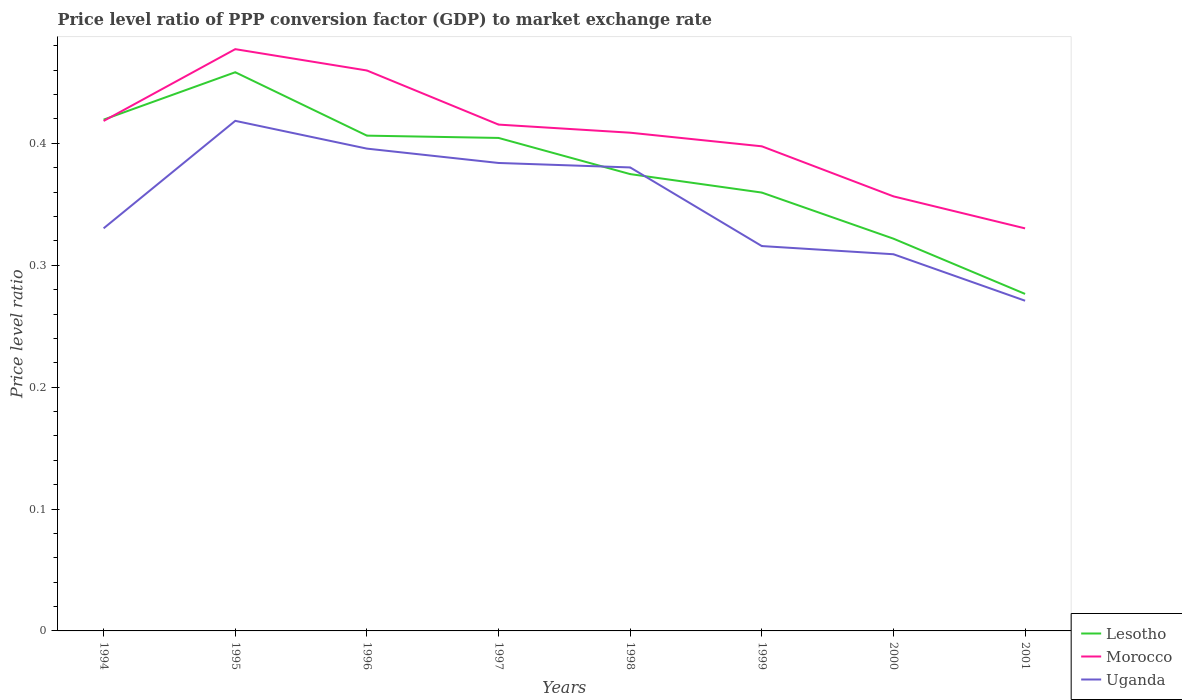How many different coloured lines are there?
Provide a short and direct response. 3. Is the number of lines equal to the number of legend labels?
Provide a succinct answer. Yes. Across all years, what is the maximum price level ratio in Lesotho?
Keep it short and to the point. 0.28. In which year was the price level ratio in Lesotho maximum?
Offer a very short reply. 2001. What is the total price level ratio in Lesotho in the graph?
Keep it short and to the point. 0.14. What is the difference between the highest and the second highest price level ratio in Uganda?
Offer a very short reply. 0.15. Is the price level ratio in Uganda strictly greater than the price level ratio in Morocco over the years?
Your response must be concise. Yes. How many years are there in the graph?
Keep it short and to the point. 8. Does the graph contain any zero values?
Make the answer very short. No. Where does the legend appear in the graph?
Make the answer very short. Bottom right. How are the legend labels stacked?
Offer a very short reply. Vertical. What is the title of the graph?
Give a very brief answer. Price level ratio of PPP conversion factor (GDP) to market exchange rate. Does "Europe(developing only)" appear as one of the legend labels in the graph?
Keep it short and to the point. No. What is the label or title of the Y-axis?
Make the answer very short. Price level ratio. What is the Price level ratio of Lesotho in 1994?
Keep it short and to the point. 0.42. What is the Price level ratio in Morocco in 1994?
Offer a very short reply. 0.42. What is the Price level ratio of Uganda in 1994?
Ensure brevity in your answer.  0.33. What is the Price level ratio of Lesotho in 1995?
Offer a very short reply. 0.46. What is the Price level ratio of Morocco in 1995?
Keep it short and to the point. 0.48. What is the Price level ratio of Uganda in 1995?
Keep it short and to the point. 0.42. What is the Price level ratio of Lesotho in 1996?
Ensure brevity in your answer.  0.41. What is the Price level ratio in Morocco in 1996?
Your response must be concise. 0.46. What is the Price level ratio in Uganda in 1996?
Ensure brevity in your answer.  0.4. What is the Price level ratio in Lesotho in 1997?
Your response must be concise. 0.4. What is the Price level ratio of Morocco in 1997?
Your answer should be very brief. 0.42. What is the Price level ratio of Uganda in 1997?
Offer a terse response. 0.38. What is the Price level ratio of Lesotho in 1998?
Provide a short and direct response. 0.37. What is the Price level ratio of Morocco in 1998?
Make the answer very short. 0.41. What is the Price level ratio of Uganda in 1998?
Your response must be concise. 0.38. What is the Price level ratio of Lesotho in 1999?
Give a very brief answer. 0.36. What is the Price level ratio in Morocco in 1999?
Offer a terse response. 0.4. What is the Price level ratio in Uganda in 1999?
Make the answer very short. 0.32. What is the Price level ratio in Lesotho in 2000?
Your answer should be very brief. 0.32. What is the Price level ratio of Morocco in 2000?
Offer a very short reply. 0.36. What is the Price level ratio in Uganda in 2000?
Offer a terse response. 0.31. What is the Price level ratio in Lesotho in 2001?
Keep it short and to the point. 0.28. What is the Price level ratio of Morocco in 2001?
Your answer should be compact. 0.33. What is the Price level ratio of Uganda in 2001?
Offer a terse response. 0.27. Across all years, what is the maximum Price level ratio in Lesotho?
Offer a very short reply. 0.46. Across all years, what is the maximum Price level ratio in Morocco?
Ensure brevity in your answer.  0.48. Across all years, what is the maximum Price level ratio in Uganda?
Ensure brevity in your answer.  0.42. Across all years, what is the minimum Price level ratio of Lesotho?
Your answer should be very brief. 0.28. Across all years, what is the minimum Price level ratio in Morocco?
Ensure brevity in your answer.  0.33. Across all years, what is the minimum Price level ratio in Uganda?
Your answer should be compact. 0.27. What is the total Price level ratio in Lesotho in the graph?
Provide a short and direct response. 3.02. What is the total Price level ratio in Morocco in the graph?
Provide a succinct answer. 3.26. What is the total Price level ratio in Uganda in the graph?
Ensure brevity in your answer.  2.8. What is the difference between the Price level ratio in Lesotho in 1994 and that in 1995?
Make the answer very short. -0.04. What is the difference between the Price level ratio in Morocco in 1994 and that in 1995?
Your answer should be compact. -0.06. What is the difference between the Price level ratio in Uganda in 1994 and that in 1995?
Provide a short and direct response. -0.09. What is the difference between the Price level ratio of Lesotho in 1994 and that in 1996?
Ensure brevity in your answer.  0.01. What is the difference between the Price level ratio in Morocco in 1994 and that in 1996?
Make the answer very short. -0.04. What is the difference between the Price level ratio in Uganda in 1994 and that in 1996?
Offer a terse response. -0.07. What is the difference between the Price level ratio in Lesotho in 1994 and that in 1997?
Make the answer very short. 0.01. What is the difference between the Price level ratio of Morocco in 1994 and that in 1997?
Give a very brief answer. 0. What is the difference between the Price level ratio in Uganda in 1994 and that in 1997?
Your answer should be compact. -0.05. What is the difference between the Price level ratio of Lesotho in 1994 and that in 1998?
Your response must be concise. 0.04. What is the difference between the Price level ratio of Morocco in 1994 and that in 1998?
Offer a very short reply. 0.01. What is the difference between the Price level ratio in Lesotho in 1994 and that in 1999?
Offer a very short reply. 0.06. What is the difference between the Price level ratio of Morocco in 1994 and that in 1999?
Your answer should be very brief. 0.02. What is the difference between the Price level ratio of Uganda in 1994 and that in 1999?
Offer a very short reply. 0.01. What is the difference between the Price level ratio of Lesotho in 1994 and that in 2000?
Your response must be concise. 0.1. What is the difference between the Price level ratio in Morocco in 1994 and that in 2000?
Your answer should be compact. 0.06. What is the difference between the Price level ratio in Uganda in 1994 and that in 2000?
Ensure brevity in your answer.  0.02. What is the difference between the Price level ratio of Lesotho in 1994 and that in 2001?
Offer a very short reply. 0.14. What is the difference between the Price level ratio in Morocco in 1994 and that in 2001?
Your answer should be very brief. 0.09. What is the difference between the Price level ratio of Uganda in 1994 and that in 2001?
Give a very brief answer. 0.06. What is the difference between the Price level ratio in Lesotho in 1995 and that in 1996?
Your answer should be compact. 0.05. What is the difference between the Price level ratio in Morocco in 1995 and that in 1996?
Provide a short and direct response. 0.02. What is the difference between the Price level ratio in Uganda in 1995 and that in 1996?
Offer a very short reply. 0.02. What is the difference between the Price level ratio in Lesotho in 1995 and that in 1997?
Provide a succinct answer. 0.05. What is the difference between the Price level ratio of Morocco in 1995 and that in 1997?
Give a very brief answer. 0.06. What is the difference between the Price level ratio in Uganda in 1995 and that in 1997?
Your answer should be very brief. 0.03. What is the difference between the Price level ratio in Lesotho in 1995 and that in 1998?
Provide a succinct answer. 0.08. What is the difference between the Price level ratio of Morocco in 1995 and that in 1998?
Keep it short and to the point. 0.07. What is the difference between the Price level ratio in Uganda in 1995 and that in 1998?
Ensure brevity in your answer.  0.04. What is the difference between the Price level ratio in Lesotho in 1995 and that in 1999?
Provide a short and direct response. 0.1. What is the difference between the Price level ratio of Morocco in 1995 and that in 1999?
Provide a succinct answer. 0.08. What is the difference between the Price level ratio in Uganda in 1995 and that in 1999?
Provide a short and direct response. 0.1. What is the difference between the Price level ratio in Lesotho in 1995 and that in 2000?
Your answer should be compact. 0.14. What is the difference between the Price level ratio of Morocco in 1995 and that in 2000?
Offer a terse response. 0.12. What is the difference between the Price level ratio in Uganda in 1995 and that in 2000?
Provide a short and direct response. 0.11. What is the difference between the Price level ratio of Lesotho in 1995 and that in 2001?
Ensure brevity in your answer.  0.18. What is the difference between the Price level ratio of Morocco in 1995 and that in 2001?
Offer a terse response. 0.15. What is the difference between the Price level ratio of Uganda in 1995 and that in 2001?
Offer a terse response. 0.15. What is the difference between the Price level ratio in Lesotho in 1996 and that in 1997?
Offer a very short reply. 0. What is the difference between the Price level ratio of Morocco in 1996 and that in 1997?
Your answer should be very brief. 0.04. What is the difference between the Price level ratio of Uganda in 1996 and that in 1997?
Offer a very short reply. 0.01. What is the difference between the Price level ratio in Lesotho in 1996 and that in 1998?
Give a very brief answer. 0.03. What is the difference between the Price level ratio of Morocco in 1996 and that in 1998?
Offer a terse response. 0.05. What is the difference between the Price level ratio in Uganda in 1996 and that in 1998?
Ensure brevity in your answer.  0.02. What is the difference between the Price level ratio in Lesotho in 1996 and that in 1999?
Offer a very short reply. 0.05. What is the difference between the Price level ratio of Morocco in 1996 and that in 1999?
Keep it short and to the point. 0.06. What is the difference between the Price level ratio in Uganda in 1996 and that in 1999?
Provide a succinct answer. 0.08. What is the difference between the Price level ratio of Lesotho in 1996 and that in 2000?
Give a very brief answer. 0.08. What is the difference between the Price level ratio of Morocco in 1996 and that in 2000?
Provide a short and direct response. 0.1. What is the difference between the Price level ratio of Uganda in 1996 and that in 2000?
Offer a terse response. 0.09. What is the difference between the Price level ratio of Lesotho in 1996 and that in 2001?
Make the answer very short. 0.13. What is the difference between the Price level ratio of Morocco in 1996 and that in 2001?
Your answer should be compact. 0.13. What is the difference between the Price level ratio in Uganda in 1996 and that in 2001?
Your answer should be compact. 0.12. What is the difference between the Price level ratio of Lesotho in 1997 and that in 1998?
Ensure brevity in your answer.  0.03. What is the difference between the Price level ratio of Morocco in 1997 and that in 1998?
Offer a very short reply. 0.01. What is the difference between the Price level ratio in Uganda in 1997 and that in 1998?
Provide a short and direct response. 0. What is the difference between the Price level ratio in Lesotho in 1997 and that in 1999?
Your response must be concise. 0.04. What is the difference between the Price level ratio in Morocco in 1997 and that in 1999?
Ensure brevity in your answer.  0.02. What is the difference between the Price level ratio of Uganda in 1997 and that in 1999?
Ensure brevity in your answer.  0.07. What is the difference between the Price level ratio of Lesotho in 1997 and that in 2000?
Your answer should be compact. 0.08. What is the difference between the Price level ratio in Morocco in 1997 and that in 2000?
Give a very brief answer. 0.06. What is the difference between the Price level ratio of Uganda in 1997 and that in 2000?
Provide a succinct answer. 0.07. What is the difference between the Price level ratio in Lesotho in 1997 and that in 2001?
Provide a short and direct response. 0.13. What is the difference between the Price level ratio of Morocco in 1997 and that in 2001?
Your answer should be compact. 0.09. What is the difference between the Price level ratio in Uganda in 1997 and that in 2001?
Ensure brevity in your answer.  0.11. What is the difference between the Price level ratio in Lesotho in 1998 and that in 1999?
Offer a very short reply. 0.02. What is the difference between the Price level ratio of Morocco in 1998 and that in 1999?
Give a very brief answer. 0.01. What is the difference between the Price level ratio of Uganda in 1998 and that in 1999?
Provide a short and direct response. 0.06. What is the difference between the Price level ratio of Lesotho in 1998 and that in 2000?
Offer a very short reply. 0.05. What is the difference between the Price level ratio of Morocco in 1998 and that in 2000?
Make the answer very short. 0.05. What is the difference between the Price level ratio in Uganda in 1998 and that in 2000?
Your response must be concise. 0.07. What is the difference between the Price level ratio of Lesotho in 1998 and that in 2001?
Provide a succinct answer. 0.1. What is the difference between the Price level ratio of Morocco in 1998 and that in 2001?
Ensure brevity in your answer.  0.08. What is the difference between the Price level ratio in Uganda in 1998 and that in 2001?
Keep it short and to the point. 0.11. What is the difference between the Price level ratio of Lesotho in 1999 and that in 2000?
Give a very brief answer. 0.04. What is the difference between the Price level ratio of Morocco in 1999 and that in 2000?
Your answer should be compact. 0.04. What is the difference between the Price level ratio in Uganda in 1999 and that in 2000?
Provide a succinct answer. 0.01. What is the difference between the Price level ratio of Lesotho in 1999 and that in 2001?
Your response must be concise. 0.08. What is the difference between the Price level ratio of Morocco in 1999 and that in 2001?
Give a very brief answer. 0.07. What is the difference between the Price level ratio of Uganda in 1999 and that in 2001?
Give a very brief answer. 0.04. What is the difference between the Price level ratio in Lesotho in 2000 and that in 2001?
Keep it short and to the point. 0.05. What is the difference between the Price level ratio of Morocco in 2000 and that in 2001?
Your answer should be very brief. 0.03. What is the difference between the Price level ratio of Uganda in 2000 and that in 2001?
Offer a terse response. 0.04. What is the difference between the Price level ratio in Lesotho in 1994 and the Price level ratio in Morocco in 1995?
Offer a terse response. -0.06. What is the difference between the Price level ratio in Morocco in 1994 and the Price level ratio in Uganda in 1995?
Your response must be concise. -0. What is the difference between the Price level ratio in Lesotho in 1994 and the Price level ratio in Morocco in 1996?
Your answer should be very brief. -0.04. What is the difference between the Price level ratio of Lesotho in 1994 and the Price level ratio of Uganda in 1996?
Ensure brevity in your answer.  0.02. What is the difference between the Price level ratio in Morocco in 1994 and the Price level ratio in Uganda in 1996?
Ensure brevity in your answer.  0.02. What is the difference between the Price level ratio of Lesotho in 1994 and the Price level ratio of Morocco in 1997?
Your response must be concise. 0. What is the difference between the Price level ratio of Lesotho in 1994 and the Price level ratio of Uganda in 1997?
Your answer should be compact. 0.04. What is the difference between the Price level ratio of Morocco in 1994 and the Price level ratio of Uganda in 1997?
Your answer should be compact. 0.03. What is the difference between the Price level ratio in Lesotho in 1994 and the Price level ratio in Morocco in 1998?
Your answer should be very brief. 0.01. What is the difference between the Price level ratio of Lesotho in 1994 and the Price level ratio of Uganda in 1998?
Offer a very short reply. 0.04. What is the difference between the Price level ratio of Morocco in 1994 and the Price level ratio of Uganda in 1998?
Provide a short and direct response. 0.04. What is the difference between the Price level ratio of Lesotho in 1994 and the Price level ratio of Morocco in 1999?
Offer a terse response. 0.02. What is the difference between the Price level ratio in Lesotho in 1994 and the Price level ratio in Uganda in 1999?
Offer a very short reply. 0.1. What is the difference between the Price level ratio of Morocco in 1994 and the Price level ratio of Uganda in 1999?
Keep it short and to the point. 0.1. What is the difference between the Price level ratio of Lesotho in 1994 and the Price level ratio of Morocco in 2000?
Provide a short and direct response. 0.06. What is the difference between the Price level ratio in Lesotho in 1994 and the Price level ratio in Uganda in 2000?
Offer a very short reply. 0.11. What is the difference between the Price level ratio in Morocco in 1994 and the Price level ratio in Uganda in 2000?
Your answer should be very brief. 0.11. What is the difference between the Price level ratio of Lesotho in 1994 and the Price level ratio of Morocco in 2001?
Provide a short and direct response. 0.09. What is the difference between the Price level ratio of Lesotho in 1994 and the Price level ratio of Uganda in 2001?
Provide a short and direct response. 0.15. What is the difference between the Price level ratio in Morocco in 1994 and the Price level ratio in Uganda in 2001?
Give a very brief answer. 0.15. What is the difference between the Price level ratio of Lesotho in 1995 and the Price level ratio of Morocco in 1996?
Your answer should be compact. -0. What is the difference between the Price level ratio in Lesotho in 1995 and the Price level ratio in Uganda in 1996?
Offer a terse response. 0.06. What is the difference between the Price level ratio of Morocco in 1995 and the Price level ratio of Uganda in 1996?
Give a very brief answer. 0.08. What is the difference between the Price level ratio of Lesotho in 1995 and the Price level ratio of Morocco in 1997?
Make the answer very short. 0.04. What is the difference between the Price level ratio of Lesotho in 1995 and the Price level ratio of Uganda in 1997?
Your response must be concise. 0.07. What is the difference between the Price level ratio of Morocco in 1995 and the Price level ratio of Uganda in 1997?
Provide a succinct answer. 0.09. What is the difference between the Price level ratio of Lesotho in 1995 and the Price level ratio of Morocco in 1998?
Your answer should be compact. 0.05. What is the difference between the Price level ratio in Lesotho in 1995 and the Price level ratio in Uganda in 1998?
Provide a short and direct response. 0.08. What is the difference between the Price level ratio in Morocco in 1995 and the Price level ratio in Uganda in 1998?
Provide a short and direct response. 0.1. What is the difference between the Price level ratio in Lesotho in 1995 and the Price level ratio in Morocco in 1999?
Your answer should be compact. 0.06. What is the difference between the Price level ratio of Lesotho in 1995 and the Price level ratio of Uganda in 1999?
Your response must be concise. 0.14. What is the difference between the Price level ratio of Morocco in 1995 and the Price level ratio of Uganda in 1999?
Your response must be concise. 0.16. What is the difference between the Price level ratio of Lesotho in 1995 and the Price level ratio of Morocco in 2000?
Offer a terse response. 0.1. What is the difference between the Price level ratio in Lesotho in 1995 and the Price level ratio in Uganda in 2000?
Your answer should be very brief. 0.15. What is the difference between the Price level ratio of Morocco in 1995 and the Price level ratio of Uganda in 2000?
Your answer should be very brief. 0.17. What is the difference between the Price level ratio in Lesotho in 1995 and the Price level ratio in Morocco in 2001?
Your answer should be compact. 0.13. What is the difference between the Price level ratio of Lesotho in 1995 and the Price level ratio of Uganda in 2001?
Ensure brevity in your answer.  0.19. What is the difference between the Price level ratio in Morocco in 1995 and the Price level ratio in Uganda in 2001?
Provide a succinct answer. 0.21. What is the difference between the Price level ratio in Lesotho in 1996 and the Price level ratio in Morocco in 1997?
Provide a succinct answer. -0.01. What is the difference between the Price level ratio of Lesotho in 1996 and the Price level ratio of Uganda in 1997?
Offer a very short reply. 0.02. What is the difference between the Price level ratio in Morocco in 1996 and the Price level ratio in Uganda in 1997?
Offer a terse response. 0.08. What is the difference between the Price level ratio in Lesotho in 1996 and the Price level ratio in Morocco in 1998?
Ensure brevity in your answer.  -0. What is the difference between the Price level ratio of Lesotho in 1996 and the Price level ratio of Uganda in 1998?
Keep it short and to the point. 0.03. What is the difference between the Price level ratio of Morocco in 1996 and the Price level ratio of Uganda in 1998?
Your response must be concise. 0.08. What is the difference between the Price level ratio of Lesotho in 1996 and the Price level ratio of Morocco in 1999?
Your answer should be compact. 0.01. What is the difference between the Price level ratio of Lesotho in 1996 and the Price level ratio of Uganda in 1999?
Offer a terse response. 0.09. What is the difference between the Price level ratio in Morocco in 1996 and the Price level ratio in Uganda in 1999?
Your response must be concise. 0.14. What is the difference between the Price level ratio in Lesotho in 1996 and the Price level ratio in Morocco in 2000?
Provide a short and direct response. 0.05. What is the difference between the Price level ratio in Lesotho in 1996 and the Price level ratio in Uganda in 2000?
Keep it short and to the point. 0.1. What is the difference between the Price level ratio of Morocco in 1996 and the Price level ratio of Uganda in 2000?
Offer a terse response. 0.15. What is the difference between the Price level ratio of Lesotho in 1996 and the Price level ratio of Morocco in 2001?
Provide a short and direct response. 0.08. What is the difference between the Price level ratio in Lesotho in 1996 and the Price level ratio in Uganda in 2001?
Give a very brief answer. 0.14. What is the difference between the Price level ratio of Morocco in 1996 and the Price level ratio of Uganda in 2001?
Your answer should be compact. 0.19. What is the difference between the Price level ratio in Lesotho in 1997 and the Price level ratio in Morocco in 1998?
Ensure brevity in your answer.  -0. What is the difference between the Price level ratio of Lesotho in 1997 and the Price level ratio of Uganda in 1998?
Your response must be concise. 0.02. What is the difference between the Price level ratio in Morocco in 1997 and the Price level ratio in Uganda in 1998?
Ensure brevity in your answer.  0.04. What is the difference between the Price level ratio of Lesotho in 1997 and the Price level ratio of Morocco in 1999?
Provide a succinct answer. 0.01. What is the difference between the Price level ratio of Lesotho in 1997 and the Price level ratio of Uganda in 1999?
Your answer should be compact. 0.09. What is the difference between the Price level ratio in Morocco in 1997 and the Price level ratio in Uganda in 1999?
Make the answer very short. 0.1. What is the difference between the Price level ratio of Lesotho in 1997 and the Price level ratio of Morocco in 2000?
Give a very brief answer. 0.05. What is the difference between the Price level ratio in Lesotho in 1997 and the Price level ratio in Uganda in 2000?
Provide a short and direct response. 0.1. What is the difference between the Price level ratio of Morocco in 1997 and the Price level ratio of Uganda in 2000?
Your answer should be compact. 0.11. What is the difference between the Price level ratio of Lesotho in 1997 and the Price level ratio of Morocco in 2001?
Offer a terse response. 0.07. What is the difference between the Price level ratio of Lesotho in 1997 and the Price level ratio of Uganda in 2001?
Your answer should be very brief. 0.13. What is the difference between the Price level ratio of Morocco in 1997 and the Price level ratio of Uganda in 2001?
Keep it short and to the point. 0.14. What is the difference between the Price level ratio of Lesotho in 1998 and the Price level ratio of Morocco in 1999?
Provide a short and direct response. -0.02. What is the difference between the Price level ratio in Lesotho in 1998 and the Price level ratio in Uganda in 1999?
Give a very brief answer. 0.06. What is the difference between the Price level ratio in Morocco in 1998 and the Price level ratio in Uganda in 1999?
Make the answer very short. 0.09. What is the difference between the Price level ratio in Lesotho in 1998 and the Price level ratio in Morocco in 2000?
Provide a succinct answer. 0.02. What is the difference between the Price level ratio in Lesotho in 1998 and the Price level ratio in Uganda in 2000?
Provide a succinct answer. 0.07. What is the difference between the Price level ratio in Morocco in 1998 and the Price level ratio in Uganda in 2000?
Provide a succinct answer. 0.1. What is the difference between the Price level ratio of Lesotho in 1998 and the Price level ratio of Morocco in 2001?
Your answer should be very brief. 0.04. What is the difference between the Price level ratio in Lesotho in 1998 and the Price level ratio in Uganda in 2001?
Provide a succinct answer. 0.1. What is the difference between the Price level ratio of Morocco in 1998 and the Price level ratio of Uganda in 2001?
Provide a short and direct response. 0.14. What is the difference between the Price level ratio of Lesotho in 1999 and the Price level ratio of Morocco in 2000?
Your answer should be very brief. 0. What is the difference between the Price level ratio in Lesotho in 1999 and the Price level ratio in Uganda in 2000?
Make the answer very short. 0.05. What is the difference between the Price level ratio in Morocco in 1999 and the Price level ratio in Uganda in 2000?
Ensure brevity in your answer.  0.09. What is the difference between the Price level ratio of Lesotho in 1999 and the Price level ratio of Morocco in 2001?
Provide a short and direct response. 0.03. What is the difference between the Price level ratio of Lesotho in 1999 and the Price level ratio of Uganda in 2001?
Provide a succinct answer. 0.09. What is the difference between the Price level ratio in Morocco in 1999 and the Price level ratio in Uganda in 2001?
Make the answer very short. 0.13. What is the difference between the Price level ratio in Lesotho in 2000 and the Price level ratio in Morocco in 2001?
Your response must be concise. -0.01. What is the difference between the Price level ratio in Lesotho in 2000 and the Price level ratio in Uganda in 2001?
Offer a terse response. 0.05. What is the difference between the Price level ratio of Morocco in 2000 and the Price level ratio of Uganda in 2001?
Make the answer very short. 0.09. What is the average Price level ratio in Lesotho per year?
Make the answer very short. 0.38. What is the average Price level ratio in Morocco per year?
Your answer should be very brief. 0.41. What is the average Price level ratio of Uganda per year?
Offer a terse response. 0.35. In the year 1994, what is the difference between the Price level ratio of Lesotho and Price level ratio of Morocco?
Provide a succinct answer. 0. In the year 1994, what is the difference between the Price level ratio in Lesotho and Price level ratio in Uganda?
Keep it short and to the point. 0.09. In the year 1994, what is the difference between the Price level ratio in Morocco and Price level ratio in Uganda?
Your response must be concise. 0.09. In the year 1995, what is the difference between the Price level ratio in Lesotho and Price level ratio in Morocco?
Your answer should be compact. -0.02. In the year 1995, what is the difference between the Price level ratio of Lesotho and Price level ratio of Uganda?
Offer a terse response. 0.04. In the year 1995, what is the difference between the Price level ratio in Morocco and Price level ratio in Uganda?
Your response must be concise. 0.06. In the year 1996, what is the difference between the Price level ratio in Lesotho and Price level ratio in Morocco?
Offer a very short reply. -0.05. In the year 1996, what is the difference between the Price level ratio in Lesotho and Price level ratio in Uganda?
Your response must be concise. 0.01. In the year 1996, what is the difference between the Price level ratio of Morocco and Price level ratio of Uganda?
Make the answer very short. 0.06. In the year 1997, what is the difference between the Price level ratio in Lesotho and Price level ratio in Morocco?
Offer a very short reply. -0.01. In the year 1997, what is the difference between the Price level ratio in Lesotho and Price level ratio in Uganda?
Your answer should be very brief. 0.02. In the year 1997, what is the difference between the Price level ratio of Morocco and Price level ratio of Uganda?
Ensure brevity in your answer.  0.03. In the year 1998, what is the difference between the Price level ratio of Lesotho and Price level ratio of Morocco?
Give a very brief answer. -0.03. In the year 1998, what is the difference between the Price level ratio in Lesotho and Price level ratio in Uganda?
Your answer should be compact. -0.01. In the year 1998, what is the difference between the Price level ratio of Morocco and Price level ratio of Uganda?
Provide a succinct answer. 0.03. In the year 1999, what is the difference between the Price level ratio of Lesotho and Price level ratio of Morocco?
Offer a very short reply. -0.04. In the year 1999, what is the difference between the Price level ratio in Lesotho and Price level ratio in Uganda?
Your answer should be very brief. 0.04. In the year 1999, what is the difference between the Price level ratio in Morocco and Price level ratio in Uganda?
Your answer should be very brief. 0.08. In the year 2000, what is the difference between the Price level ratio of Lesotho and Price level ratio of Morocco?
Offer a very short reply. -0.03. In the year 2000, what is the difference between the Price level ratio in Lesotho and Price level ratio in Uganda?
Offer a very short reply. 0.01. In the year 2000, what is the difference between the Price level ratio in Morocco and Price level ratio in Uganda?
Make the answer very short. 0.05. In the year 2001, what is the difference between the Price level ratio of Lesotho and Price level ratio of Morocco?
Make the answer very short. -0.05. In the year 2001, what is the difference between the Price level ratio in Lesotho and Price level ratio in Uganda?
Provide a short and direct response. 0.01. In the year 2001, what is the difference between the Price level ratio in Morocco and Price level ratio in Uganda?
Make the answer very short. 0.06. What is the ratio of the Price level ratio of Lesotho in 1994 to that in 1995?
Give a very brief answer. 0.92. What is the ratio of the Price level ratio in Morocco in 1994 to that in 1995?
Your answer should be compact. 0.88. What is the ratio of the Price level ratio in Uganda in 1994 to that in 1995?
Offer a very short reply. 0.79. What is the ratio of the Price level ratio in Lesotho in 1994 to that in 1996?
Offer a terse response. 1.03. What is the ratio of the Price level ratio of Morocco in 1994 to that in 1996?
Provide a short and direct response. 0.91. What is the ratio of the Price level ratio of Uganda in 1994 to that in 1996?
Offer a very short reply. 0.83. What is the ratio of the Price level ratio in Lesotho in 1994 to that in 1997?
Provide a short and direct response. 1.04. What is the ratio of the Price level ratio of Uganda in 1994 to that in 1997?
Offer a terse response. 0.86. What is the ratio of the Price level ratio in Lesotho in 1994 to that in 1998?
Make the answer very short. 1.12. What is the ratio of the Price level ratio of Morocco in 1994 to that in 1998?
Provide a short and direct response. 1.02. What is the ratio of the Price level ratio in Uganda in 1994 to that in 1998?
Give a very brief answer. 0.87. What is the ratio of the Price level ratio of Lesotho in 1994 to that in 1999?
Give a very brief answer. 1.17. What is the ratio of the Price level ratio of Morocco in 1994 to that in 1999?
Give a very brief answer. 1.05. What is the ratio of the Price level ratio of Uganda in 1994 to that in 1999?
Ensure brevity in your answer.  1.05. What is the ratio of the Price level ratio of Lesotho in 1994 to that in 2000?
Keep it short and to the point. 1.3. What is the ratio of the Price level ratio of Morocco in 1994 to that in 2000?
Your response must be concise. 1.17. What is the ratio of the Price level ratio in Uganda in 1994 to that in 2000?
Offer a terse response. 1.07. What is the ratio of the Price level ratio of Lesotho in 1994 to that in 2001?
Offer a terse response. 1.52. What is the ratio of the Price level ratio of Morocco in 1994 to that in 2001?
Offer a terse response. 1.27. What is the ratio of the Price level ratio in Uganda in 1994 to that in 2001?
Offer a terse response. 1.22. What is the ratio of the Price level ratio of Lesotho in 1995 to that in 1996?
Provide a short and direct response. 1.13. What is the ratio of the Price level ratio of Morocco in 1995 to that in 1996?
Ensure brevity in your answer.  1.04. What is the ratio of the Price level ratio in Uganda in 1995 to that in 1996?
Ensure brevity in your answer.  1.06. What is the ratio of the Price level ratio of Lesotho in 1995 to that in 1997?
Your answer should be compact. 1.13. What is the ratio of the Price level ratio in Morocco in 1995 to that in 1997?
Your response must be concise. 1.15. What is the ratio of the Price level ratio in Uganda in 1995 to that in 1997?
Offer a very short reply. 1.09. What is the ratio of the Price level ratio of Lesotho in 1995 to that in 1998?
Make the answer very short. 1.22. What is the ratio of the Price level ratio in Morocco in 1995 to that in 1998?
Give a very brief answer. 1.17. What is the ratio of the Price level ratio in Uganda in 1995 to that in 1998?
Offer a terse response. 1.1. What is the ratio of the Price level ratio in Lesotho in 1995 to that in 1999?
Offer a terse response. 1.27. What is the ratio of the Price level ratio in Morocco in 1995 to that in 1999?
Offer a terse response. 1.2. What is the ratio of the Price level ratio in Uganda in 1995 to that in 1999?
Ensure brevity in your answer.  1.33. What is the ratio of the Price level ratio of Lesotho in 1995 to that in 2000?
Provide a short and direct response. 1.42. What is the ratio of the Price level ratio of Morocco in 1995 to that in 2000?
Keep it short and to the point. 1.34. What is the ratio of the Price level ratio of Uganda in 1995 to that in 2000?
Offer a terse response. 1.35. What is the ratio of the Price level ratio of Lesotho in 1995 to that in 2001?
Provide a succinct answer. 1.66. What is the ratio of the Price level ratio of Morocco in 1995 to that in 2001?
Offer a terse response. 1.45. What is the ratio of the Price level ratio of Uganda in 1995 to that in 2001?
Offer a very short reply. 1.54. What is the ratio of the Price level ratio of Lesotho in 1996 to that in 1997?
Make the answer very short. 1. What is the ratio of the Price level ratio in Morocco in 1996 to that in 1997?
Offer a very short reply. 1.11. What is the ratio of the Price level ratio in Uganda in 1996 to that in 1997?
Provide a short and direct response. 1.03. What is the ratio of the Price level ratio of Lesotho in 1996 to that in 1998?
Keep it short and to the point. 1.08. What is the ratio of the Price level ratio in Morocco in 1996 to that in 1998?
Your answer should be very brief. 1.12. What is the ratio of the Price level ratio in Uganda in 1996 to that in 1998?
Provide a short and direct response. 1.04. What is the ratio of the Price level ratio in Lesotho in 1996 to that in 1999?
Your answer should be compact. 1.13. What is the ratio of the Price level ratio in Morocco in 1996 to that in 1999?
Give a very brief answer. 1.16. What is the ratio of the Price level ratio in Uganda in 1996 to that in 1999?
Your answer should be compact. 1.25. What is the ratio of the Price level ratio in Lesotho in 1996 to that in 2000?
Your response must be concise. 1.26. What is the ratio of the Price level ratio of Morocco in 1996 to that in 2000?
Your response must be concise. 1.29. What is the ratio of the Price level ratio of Uganda in 1996 to that in 2000?
Provide a short and direct response. 1.28. What is the ratio of the Price level ratio of Lesotho in 1996 to that in 2001?
Ensure brevity in your answer.  1.47. What is the ratio of the Price level ratio of Morocco in 1996 to that in 2001?
Your answer should be very brief. 1.39. What is the ratio of the Price level ratio of Uganda in 1996 to that in 2001?
Offer a terse response. 1.46. What is the ratio of the Price level ratio of Lesotho in 1997 to that in 1998?
Provide a succinct answer. 1.08. What is the ratio of the Price level ratio in Morocco in 1997 to that in 1998?
Ensure brevity in your answer.  1.02. What is the ratio of the Price level ratio in Uganda in 1997 to that in 1998?
Provide a succinct answer. 1.01. What is the ratio of the Price level ratio of Lesotho in 1997 to that in 1999?
Keep it short and to the point. 1.12. What is the ratio of the Price level ratio in Morocco in 1997 to that in 1999?
Provide a short and direct response. 1.04. What is the ratio of the Price level ratio of Uganda in 1997 to that in 1999?
Provide a short and direct response. 1.22. What is the ratio of the Price level ratio in Lesotho in 1997 to that in 2000?
Offer a very short reply. 1.26. What is the ratio of the Price level ratio of Morocco in 1997 to that in 2000?
Your response must be concise. 1.17. What is the ratio of the Price level ratio of Uganda in 1997 to that in 2000?
Offer a very short reply. 1.24. What is the ratio of the Price level ratio of Lesotho in 1997 to that in 2001?
Provide a succinct answer. 1.46. What is the ratio of the Price level ratio in Morocco in 1997 to that in 2001?
Provide a short and direct response. 1.26. What is the ratio of the Price level ratio in Uganda in 1997 to that in 2001?
Make the answer very short. 1.42. What is the ratio of the Price level ratio of Lesotho in 1998 to that in 1999?
Offer a terse response. 1.04. What is the ratio of the Price level ratio of Morocco in 1998 to that in 1999?
Offer a terse response. 1.03. What is the ratio of the Price level ratio of Uganda in 1998 to that in 1999?
Make the answer very short. 1.2. What is the ratio of the Price level ratio in Lesotho in 1998 to that in 2000?
Provide a short and direct response. 1.16. What is the ratio of the Price level ratio in Morocco in 1998 to that in 2000?
Your answer should be very brief. 1.15. What is the ratio of the Price level ratio in Uganda in 1998 to that in 2000?
Make the answer very short. 1.23. What is the ratio of the Price level ratio in Lesotho in 1998 to that in 2001?
Make the answer very short. 1.36. What is the ratio of the Price level ratio in Morocco in 1998 to that in 2001?
Give a very brief answer. 1.24. What is the ratio of the Price level ratio of Uganda in 1998 to that in 2001?
Offer a terse response. 1.4. What is the ratio of the Price level ratio in Lesotho in 1999 to that in 2000?
Give a very brief answer. 1.12. What is the ratio of the Price level ratio in Morocco in 1999 to that in 2000?
Give a very brief answer. 1.12. What is the ratio of the Price level ratio in Uganda in 1999 to that in 2000?
Your answer should be very brief. 1.02. What is the ratio of the Price level ratio of Lesotho in 1999 to that in 2001?
Offer a very short reply. 1.3. What is the ratio of the Price level ratio of Morocco in 1999 to that in 2001?
Make the answer very short. 1.2. What is the ratio of the Price level ratio of Uganda in 1999 to that in 2001?
Offer a terse response. 1.17. What is the ratio of the Price level ratio of Lesotho in 2000 to that in 2001?
Give a very brief answer. 1.16. What is the ratio of the Price level ratio of Morocco in 2000 to that in 2001?
Offer a terse response. 1.08. What is the ratio of the Price level ratio in Uganda in 2000 to that in 2001?
Offer a very short reply. 1.14. What is the difference between the highest and the second highest Price level ratio in Lesotho?
Make the answer very short. 0.04. What is the difference between the highest and the second highest Price level ratio of Morocco?
Offer a terse response. 0.02. What is the difference between the highest and the second highest Price level ratio in Uganda?
Ensure brevity in your answer.  0.02. What is the difference between the highest and the lowest Price level ratio in Lesotho?
Provide a short and direct response. 0.18. What is the difference between the highest and the lowest Price level ratio in Morocco?
Offer a terse response. 0.15. What is the difference between the highest and the lowest Price level ratio in Uganda?
Offer a very short reply. 0.15. 